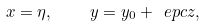Convert formula to latex. <formula><loc_0><loc_0><loc_500><loc_500>x = \eta , \quad y = y _ { 0 } + \ e p c z ,</formula> 